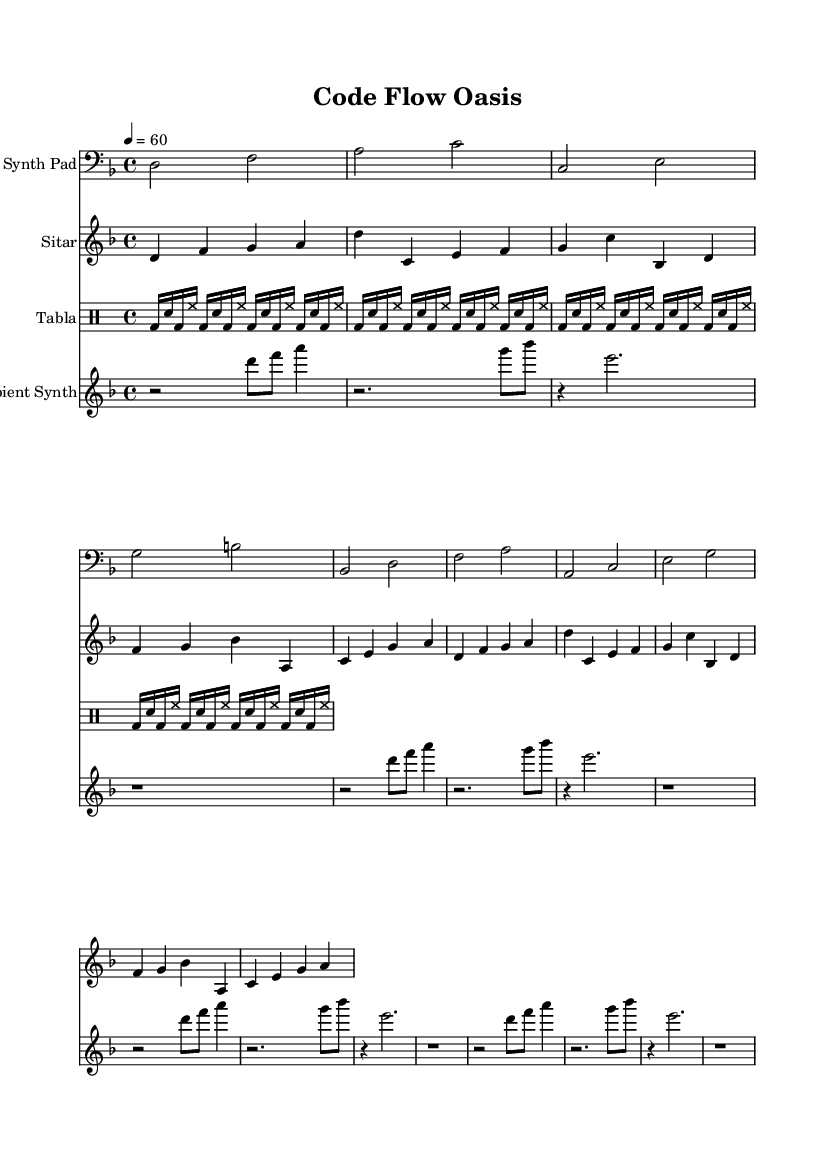What is the key signature of this music? The key signature shows two flats, indicating that the key is D minor, as it has one flat (B flat) which is typical for this minor key.
Answer: D minor What is the time signature of this music? The time signature is 4/4, which can be seen at the beginning of the music indicating four beats per measure.
Answer: 4/4 What is the tempo marking of this piece? The tempo is indicated at the beginning with "4 = 60," meaning that a quarter note is set to a speed of 60 beats per minute.
Answer: 60 How many measures are in the sitar part? The sitar part contains eight measures, as counted directly from the notation present in the staff.
Answer: Eight Which instruments are involved in this composition? The composition features a Synth Pad, Sitar, Tabla, and Ambient Synth, as indicated in their respective staff labels.
Answer: Synth Pad, Sitar, Tabla, Ambient Synth What rhythmic pattern is used for the tabla? The rhythmic pattern consists of a bass drum followed by a snare and hi-hat, repeated across four measures, which emphasizes a traditional beat structure commonly found in world music.
Answer: Bass, snare, hi-hat Which instrument has a rhythmic rest in its melody? The Ambient Synth prominently features a rhythmic rest symbol at the beginning of the third measure, indicating moments of silence within its phrases.
Answer: Ambient Synth 